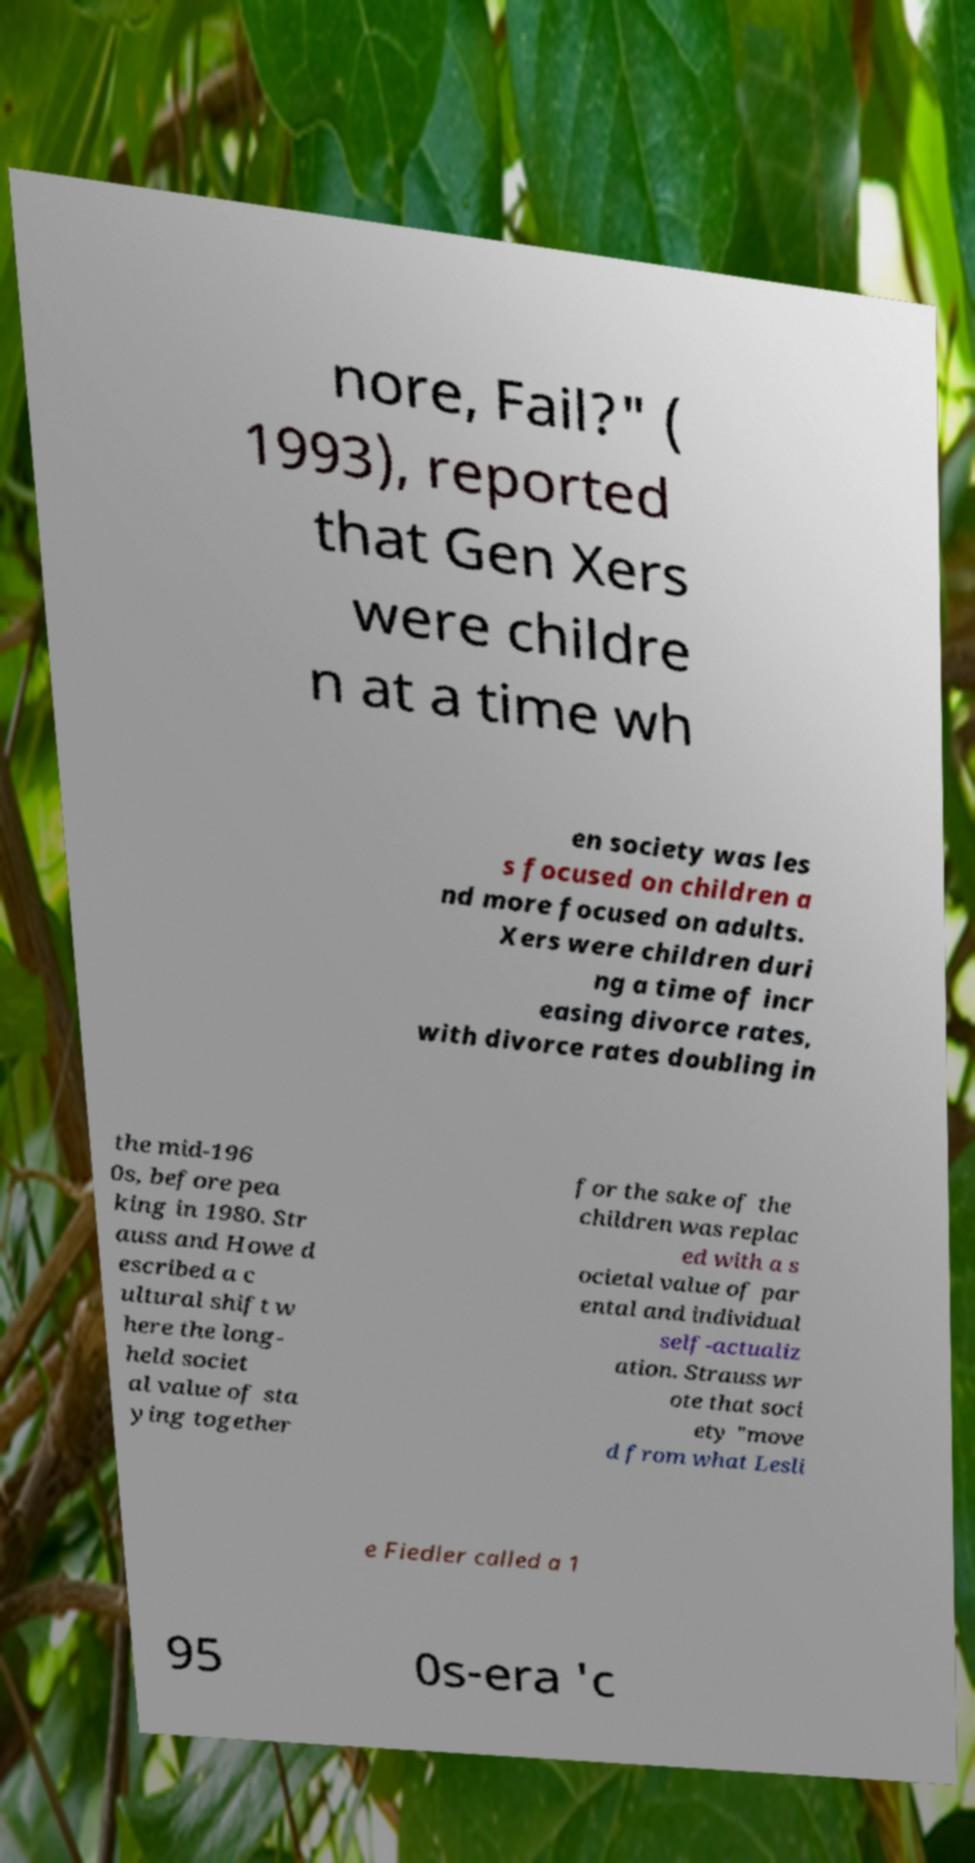I need the written content from this picture converted into text. Can you do that? nore, Fail?" ( 1993), reported that Gen Xers were childre n at a time wh en society was les s focused on children a nd more focused on adults. Xers were children duri ng a time of incr easing divorce rates, with divorce rates doubling in the mid-196 0s, before pea king in 1980. Str auss and Howe d escribed a c ultural shift w here the long- held societ al value of sta ying together for the sake of the children was replac ed with a s ocietal value of par ental and individual self-actualiz ation. Strauss wr ote that soci ety "move d from what Lesli e Fiedler called a 1 95 0s-era 'c 